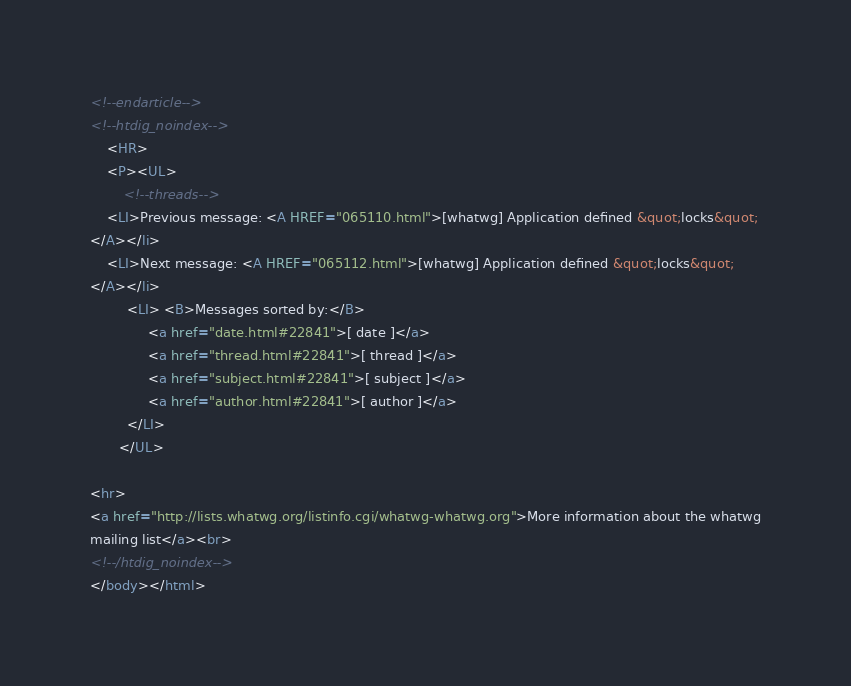<code> <loc_0><loc_0><loc_500><loc_500><_HTML_>































<!--endarticle-->
<!--htdig_noindex-->
    <HR>
    <P><UL>
        <!--threads-->
	<LI>Previous message: <A HREF="065110.html">[whatwg] Application defined &quot;locks&quot;
</A></li>
	<LI>Next message: <A HREF="065112.html">[whatwg] Application defined &quot;locks&quot;
</A></li>
         <LI> <B>Messages sorted by:</B> 
              <a href="date.html#22841">[ date ]</a>
              <a href="thread.html#22841">[ thread ]</a>
              <a href="subject.html#22841">[ subject ]</a>
              <a href="author.html#22841">[ author ]</a>
         </LI>
       </UL>

<hr>
<a href="http://lists.whatwg.org/listinfo.cgi/whatwg-whatwg.org">More information about the whatwg
mailing list</a><br>
<!--/htdig_noindex-->
</body></html>
</code> 